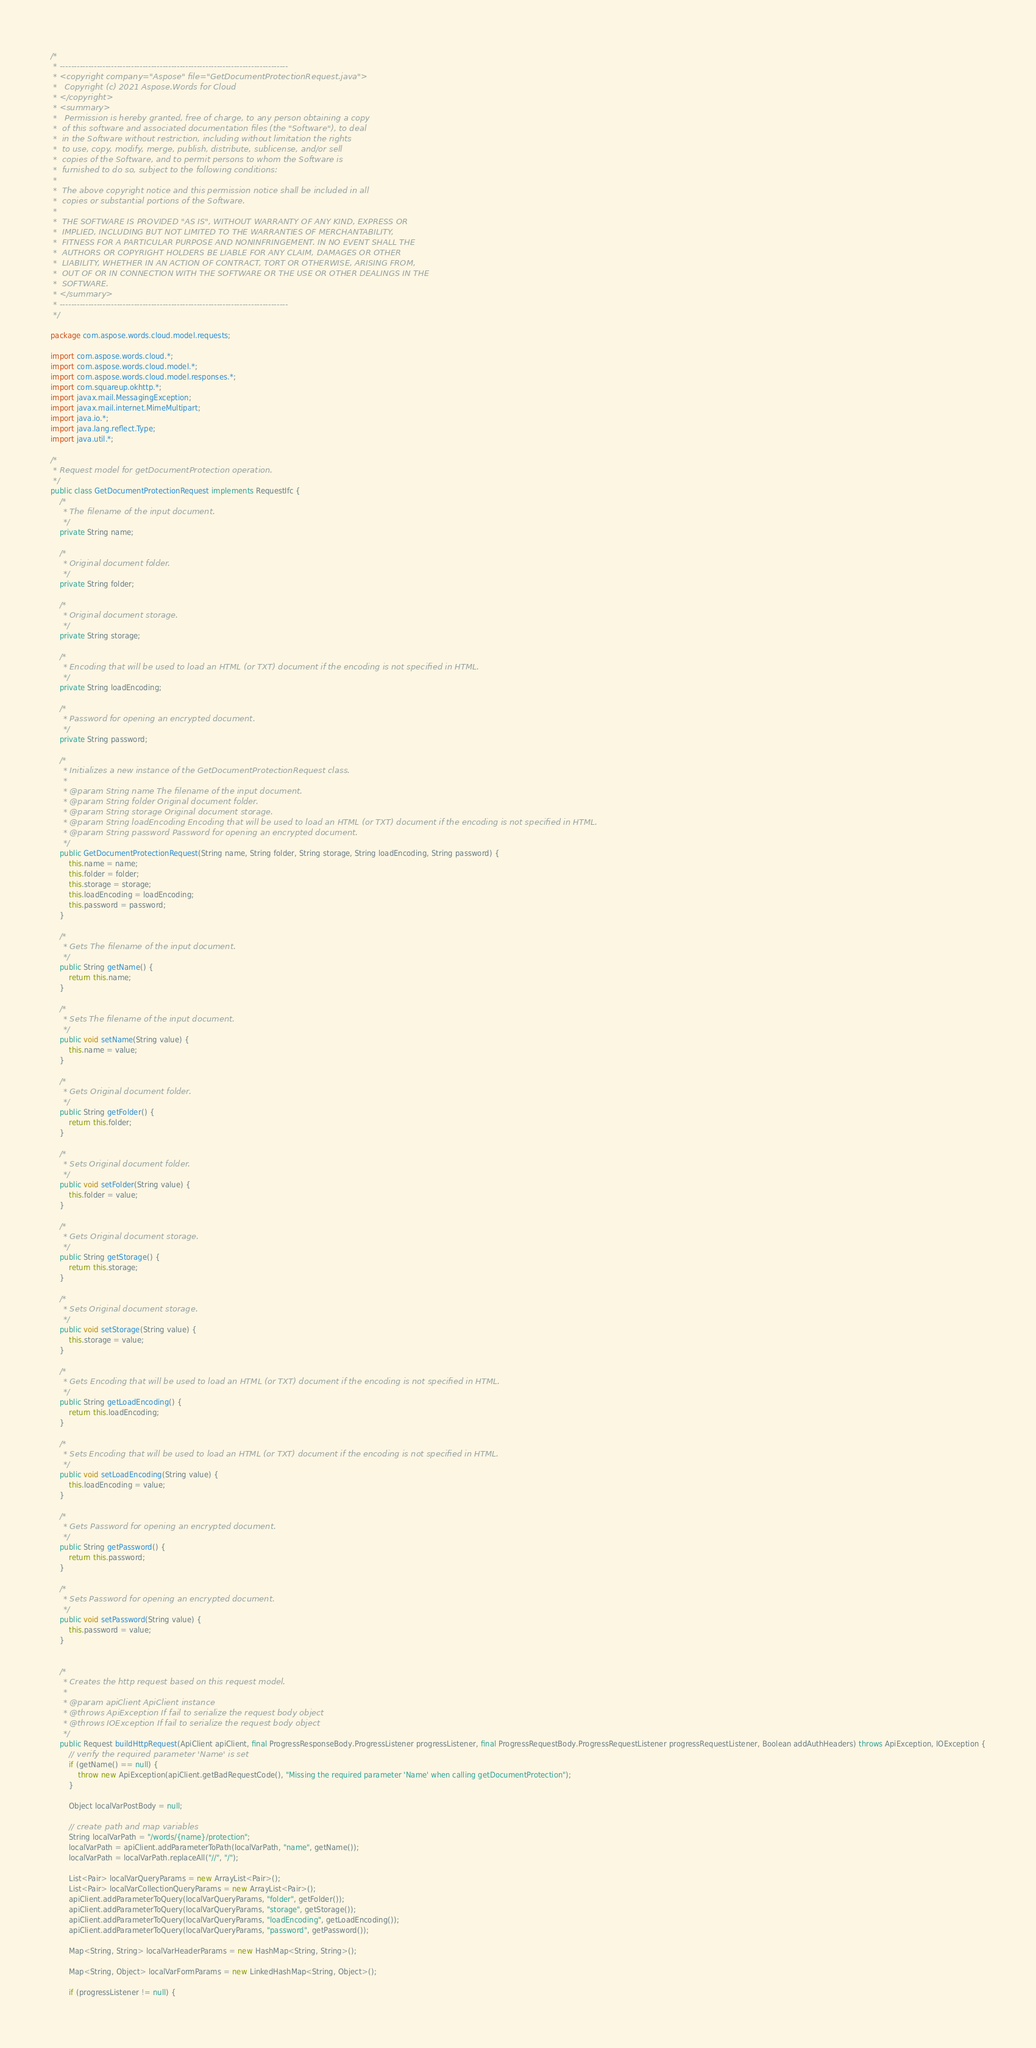Convert code to text. <code><loc_0><loc_0><loc_500><loc_500><_Java_>/*
 * --------------------------------------------------------------------------------
 * <copyright company="Aspose" file="GetDocumentProtectionRequest.java">
 *   Copyright (c) 2021 Aspose.Words for Cloud
 * </copyright>
 * <summary>
 *   Permission is hereby granted, free of charge, to any person obtaining a copy
 *  of this software and associated documentation files (the "Software"), to deal
 *  in the Software without restriction, including without limitation the rights
 *  to use, copy, modify, merge, publish, distribute, sublicense, and/or sell
 *  copies of the Software, and to permit persons to whom the Software is
 *  furnished to do so, subject to the following conditions:
 * 
 *  The above copyright notice and this permission notice shall be included in all
 *  copies or substantial portions of the Software.
 * 
 *  THE SOFTWARE IS PROVIDED "AS IS", WITHOUT WARRANTY OF ANY KIND, EXPRESS OR
 *  IMPLIED, INCLUDING BUT NOT LIMITED TO THE WARRANTIES OF MERCHANTABILITY,
 *  FITNESS FOR A PARTICULAR PURPOSE AND NONINFRINGEMENT. IN NO EVENT SHALL THE
 *  AUTHORS OR COPYRIGHT HOLDERS BE LIABLE FOR ANY CLAIM, DAMAGES OR OTHER
 *  LIABILITY, WHETHER IN AN ACTION OF CONTRACT, TORT OR OTHERWISE, ARISING FROM,
 *  OUT OF OR IN CONNECTION WITH THE SOFTWARE OR THE USE OR OTHER DEALINGS IN THE
 *  SOFTWARE.
 * </summary>
 * --------------------------------------------------------------------------------
 */

package com.aspose.words.cloud.model.requests;

import com.aspose.words.cloud.*;
import com.aspose.words.cloud.model.*;
import com.aspose.words.cloud.model.responses.*;
import com.squareup.okhttp.*;
import javax.mail.MessagingException;
import javax.mail.internet.MimeMultipart;
import java.io.*;
import java.lang.reflect.Type;
import java.util.*;

/*
 * Request model for getDocumentProtection operation.
 */
public class GetDocumentProtectionRequest implements RequestIfc {
    /*
     * The filename of the input document.
     */
    private String name;

    /*
     * Original document folder.
     */
    private String folder;

    /*
     * Original document storage.
     */
    private String storage;

    /*
     * Encoding that will be used to load an HTML (or TXT) document if the encoding is not specified in HTML.
     */
    private String loadEncoding;

    /*
     * Password for opening an encrypted document.
     */
    private String password;

    /*
     * Initializes a new instance of the GetDocumentProtectionRequest class.
     *
     * @param String name The filename of the input document.
     * @param String folder Original document folder.
     * @param String storage Original document storage.
     * @param String loadEncoding Encoding that will be used to load an HTML (or TXT) document if the encoding is not specified in HTML.
     * @param String password Password for opening an encrypted document.
     */
    public GetDocumentProtectionRequest(String name, String folder, String storage, String loadEncoding, String password) {
        this.name = name;
        this.folder = folder;
        this.storage = storage;
        this.loadEncoding = loadEncoding;
        this.password = password;
    }

    /*
     * Gets The filename of the input document.
     */
    public String getName() {
        return this.name;
    }

    /*
     * Sets The filename of the input document.
     */
    public void setName(String value) {
        this.name = value;
    }

    /*
     * Gets Original document folder.
     */
    public String getFolder() {
        return this.folder;
    }

    /*
     * Sets Original document folder.
     */
    public void setFolder(String value) {
        this.folder = value;
    }

    /*
     * Gets Original document storage.
     */
    public String getStorage() {
        return this.storage;
    }

    /*
     * Sets Original document storage.
     */
    public void setStorage(String value) {
        this.storage = value;
    }

    /*
     * Gets Encoding that will be used to load an HTML (or TXT) document if the encoding is not specified in HTML.
     */
    public String getLoadEncoding() {
        return this.loadEncoding;
    }

    /*
     * Sets Encoding that will be used to load an HTML (or TXT) document if the encoding is not specified in HTML.
     */
    public void setLoadEncoding(String value) {
        this.loadEncoding = value;
    }

    /*
     * Gets Password for opening an encrypted document.
     */
    public String getPassword() {
        return this.password;
    }

    /*
     * Sets Password for opening an encrypted document.
     */
    public void setPassword(String value) {
        this.password = value;
    }


    /*
     * Creates the http request based on this request model.
     *
     * @param apiClient ApiClient instance
     * @throws ApiException If fail to serialize the request body object
     * @throws IOException If fail to serialize the request body object
     */
    public Request buildHttpRequest(ApiClient apiClient, final ProgressResponseBody.ProgressListener progressListener, final ProgressRequestBody.ProgressRequestListener progressRequestListener, Boolean addAuthHeaders) throws ApiException, IOException {
        // verify the required parameter 'Name' is set
        if (getName() == null) {
            throw new ApiException(apiClient.getBadRequestCode(), "Missing the required parameter 'Name' when calling getDocumentProtection");
        }

        Object localVarPostBody = null;

        // create path and map variables
        String localVarPath = "/words/{name}/protection";
        localVarPath = apiClient.addParameterToPath(localVarPath, "name", getName());
        localVarPath = localVarPath.replaceAll("//", "/");

        List<Pair> localVarQueryParams = new ArrayList<Pair>();
        List<Pair> localVarCollectionQueryParams = new ArrayList<Pair>();
        apiClient.addParameterToQuery(localVarQueryParams, "folder", getFolder());
        apiClient.addParameterToQuery(localVarQueryParams, "storage", getStorage());
        apiClient.addParameterToQuery(localVarQueryParams, "loadEncoding", getLoadEncoding());
        apiClient.addParameterToQuery(localVarQueryParams, "password", getPassword());

        Map<String, String> localVarHeaderParams = new HashMap<String, String>();

        Map<String, Object> localVarFormParams = new LinkedHashMap<String, Object>();

        if (progressListener != null) {</code> 